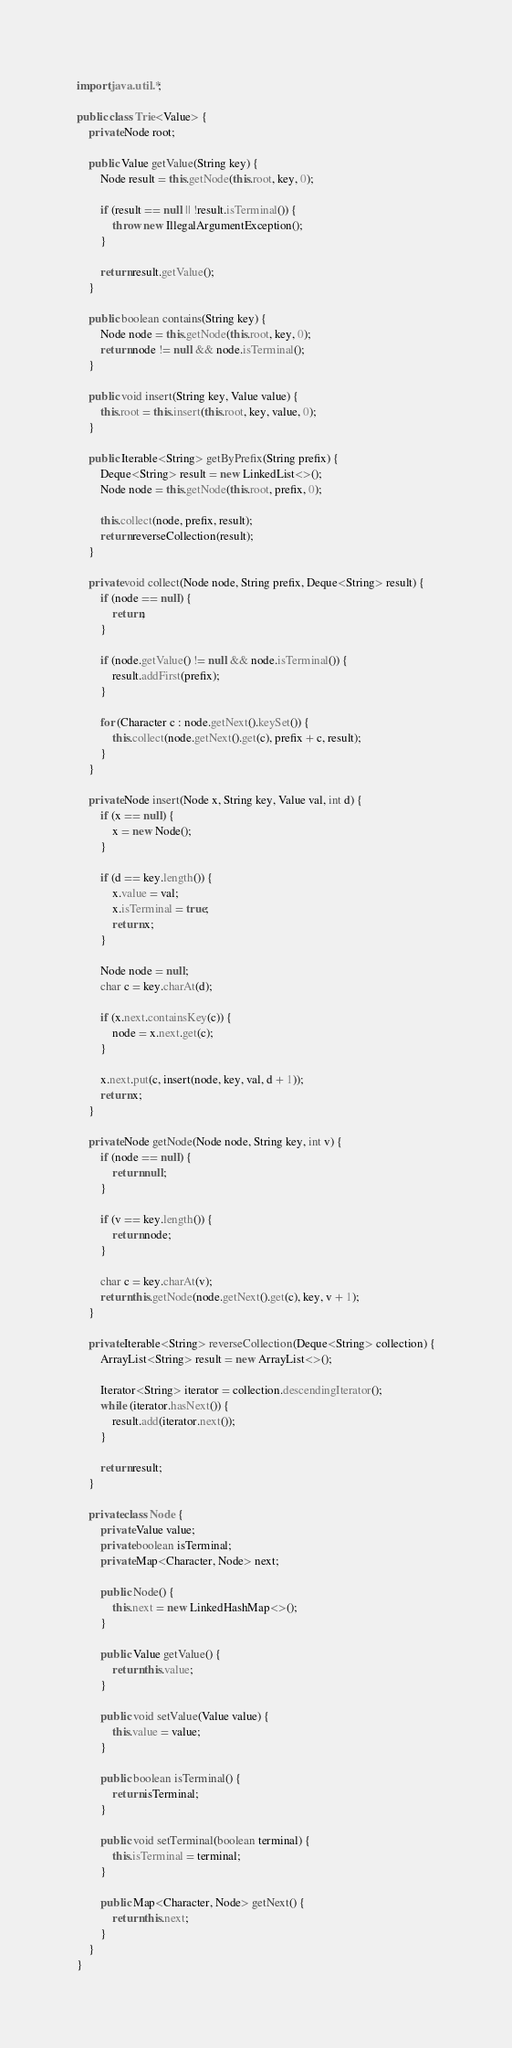Convert code to text. <code><loc_0><loc_0><loc_500><loc_500><_Java_>import java.util.*;

public class Trie<Value> {
    private Node root;

    public Value getValue(String key) {
        Node result = this.getNode(this.root, key, 0);

        if (result == null || !result.isTerminal()) {
            throw new IllegalArgumentException();
        }

        return result.getValue();
    }

    public boolean contains(String key) {
        Node node = this.getNode(this.root, key, 0);
        return node != null && node.isTerminal();
    }

    public void insert(String key, Value value) {
        this.root = this.insert(this.root, key, value, 0);
    }

    public Iterable<String> getByPrefix(String prefix) {
        Deque<String> result = new LinkedList<>();
        Node node = this.getNode(this.root, prefix, 0);

        this.collect(node, prefix, result);
        return reverseCollection(result);
    }

    private void collect(Node node, String prefix, Deque<String> result) {
        if (node == null) {
            return;
        }

        if (node.getValue() != null && node.isTerminal()) {
            result.addFirst(prefix);
        }

        for (Character c : node.getNext().keySet()) {
            this.collect(node.getNext().get(c), prefix + c, result);
        }
    }

    private Node insert(Node x, String key, Value val, int d) {
        if (x == null) {
            x = new Node();
        }

        if (d == key.length()) {
            x.value = val;
            x.isTerminal = true;
            return x;
        }

        Node node = null;
        char c = key.charAt(d);

        if (x.next.containsKey(c)) {
            node = x.next.get(c);
        }

        x.next.put(c, insert(node, key, val, d + 1));
        return x;
    }

    private Node getNode(Node node, String key, int v) {
        if (node == null) {
            return null;
        }

        if (v == key.length()) {
            return node;
        }

        char c = key.charAt(v);
        return this.getNode(node.getNext().get(c), key, v + 1);
    }

    private Iterable<String> reverseCollection(Deque<String> collection) {
        ArrayList<String> result = new ArrayList<>();

        Iterator<String> iterator = collection.descendingIterator();
        while (iterator.hasNext()) {
            result.add(iterator.next());
        }

        return result;
    }

    private class Node {
        private Value value;
        private boolean isTerminal;
        private Map<Character, Node> next;

        public Node() {
            this.next = new LinkedHashMap<>();
        }

        public Value getValue() {
            return this.value;
        }

        public void setValue(Value value) {
            this.value = value;
        }

        public boolean isTerminal() {
            return isTerminal;
        }

        public void setTerminal(boolean terminal) {
            this.isTerminal = terminal;
        }

        public Map<Character, Node> getNext() {
            return this.next;
        }
    }
}
</code> 